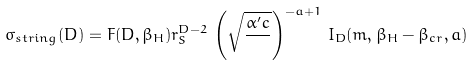Convert formula to latex. <formula><loc_0><loc_0><loc_500><loc_500>\sigma _ { s t r i n g } ( D ) = F ( D , \beta _ { H } ) r _ { S } ^ { D - 2 } \, \left ( \sqrt { \frac { \alpha ^ { \prime } c } { } } \right ) ^ { - a + 1 } \, I _ { D } ( m , \beta _ { H } - \beta _ { c r } , a )</formula> 